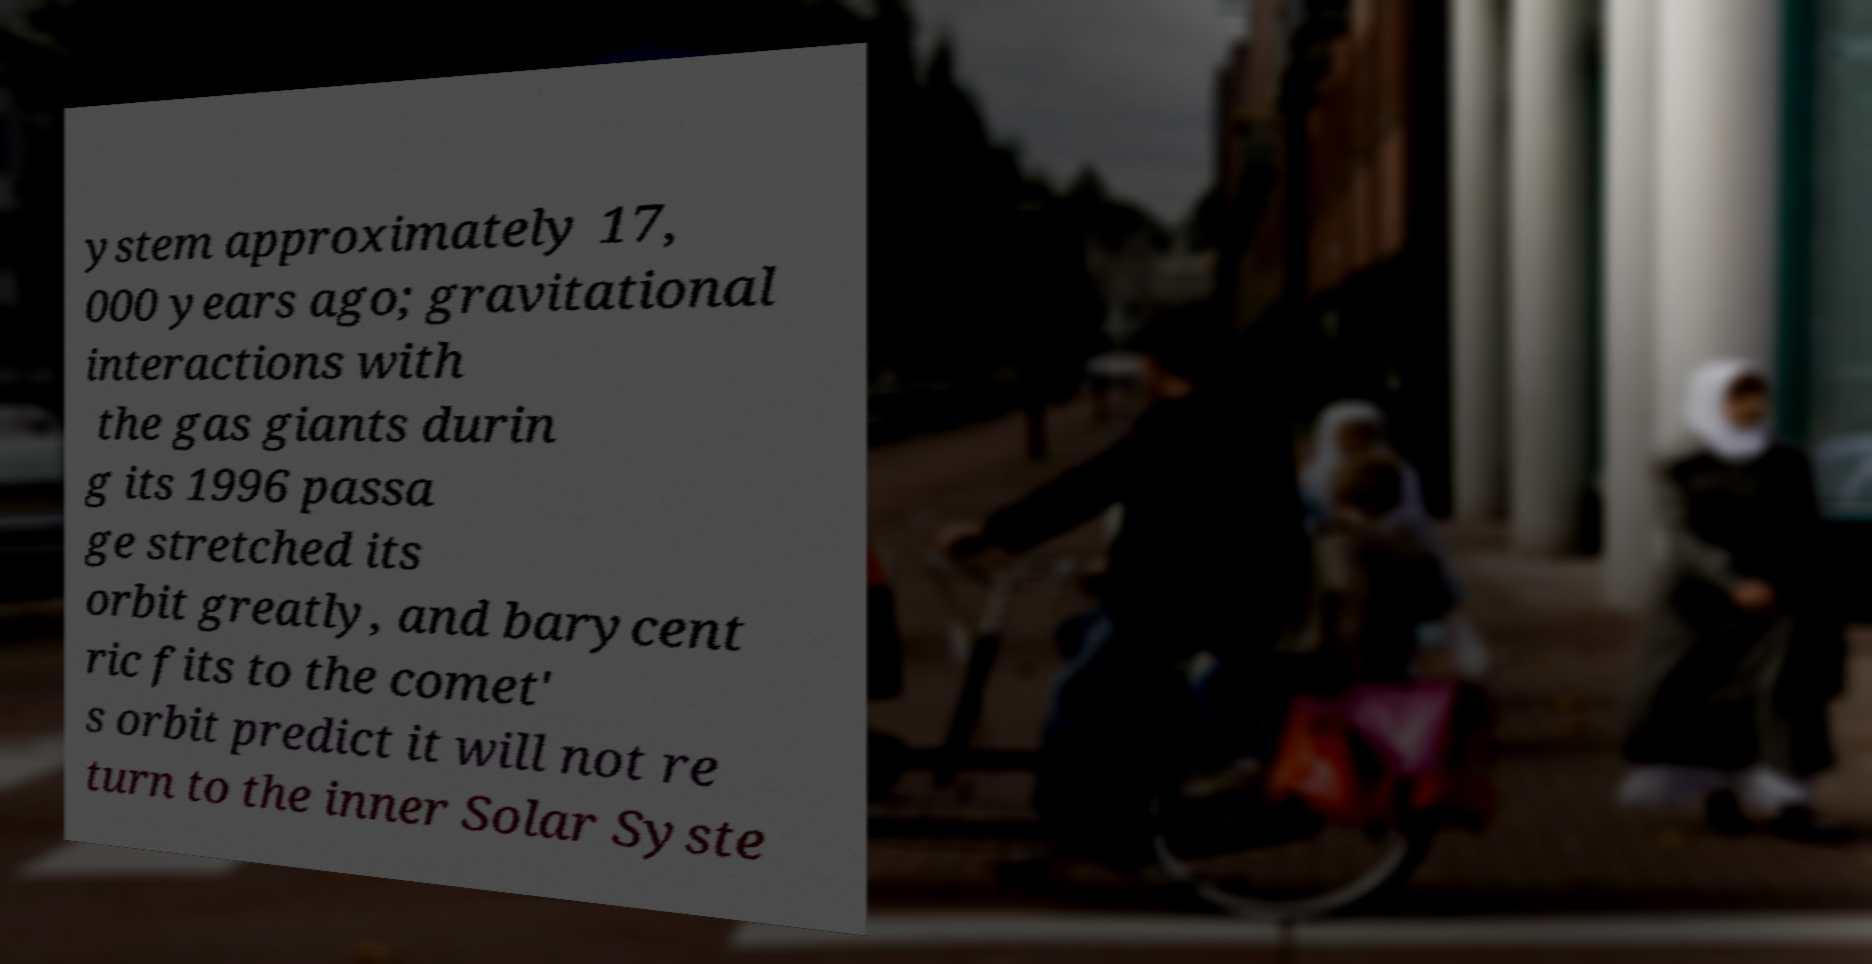Could you extract and type out the text from this image? ystem approximately 17, 000 years ago; gravitational interactions with the gas giants durin g its 1996 passa ge stretched its orbit greatly, and barycent ric fits to the comet' s orbit predict it will not re turn to the inner Solar Syste 